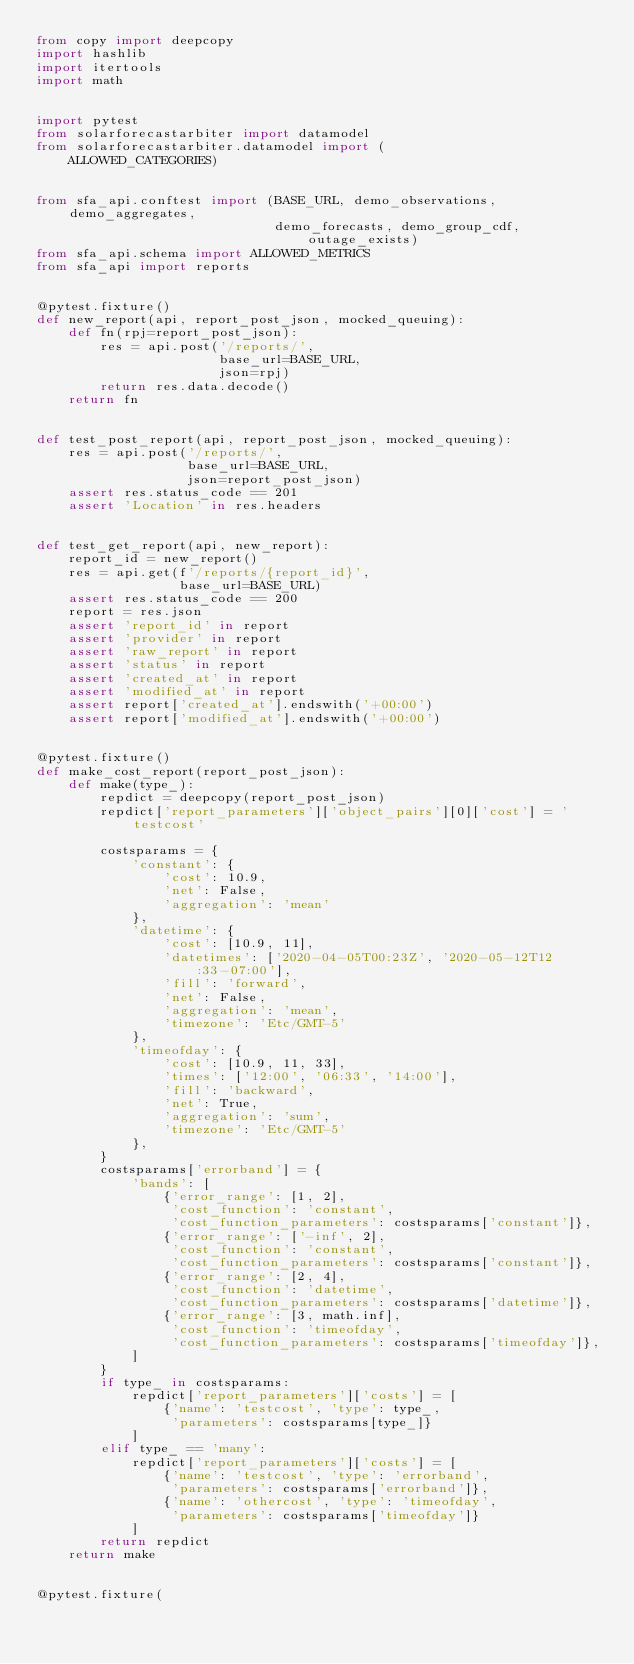Convert code to text. <code><loc_0><loc_0><loc_500><loc_500><_Python_>from copy import deepcopy
import hashlib
import itertools
import math


import pytest
from solarforecastarbiter import datamodel
from solarforecastarbiter.datamodel import (
    ALLOWED_CATEGORIES)


from sfa_api.conftest import (BASE_URL, demo_observations, demo_aggregates,
                              demo_forecasts, demo_group_cdf, outage_exists)
from sfa_api.schema import ALLOWED_METRICS
from sfa_api import reports


@pytest.fixture()
def new_report(api, report_post_json, mocked_queuing):
    def fn(rpj=report_post_json):
        res = api.post('/reports/',
                       base_url=BASE_URL,
                       json=rpj)
        return res.data.decode()
    return fn


def test_post_report(api, report_post_json, mocked_queuing):
    res = api.post('/reports/',
                   base_url=BASE_URL,
                   json=report_post_json)
    assert res.status_code == 201
    assert 'Location' in res.headers


def test_get_report(api, new_report):
    report_id = new_report()
    res = api.get(f'/reports/{report_id}',
                  base_url=BASE_URL)
    assert res.status_code == 200
    report = res.json
    assert 'report_id' in report
    assert 'provider' in report
    assert 'raw_report' in report
    assert 'status' in report
    assert 'created_at' in report
    assert 'modified_at' in report
    assert report['created_at'].endswith('+00:00')
    assert report['modified_at'].endswith('+00:00')


@pytest.fixture()
def make_cost_report(report_post_json):
    def make(type_):
        repdict = deepcopy(report_post_json)
        repdict['report_parameters']['object_pairs'][0]['cost'] = 'testcost'

        costsparams = {
            'constant': {
                'cost': 10.9,
                'net': False,
                'aggregation': 'mean'
            },
            'datetime': {
                'cost': [10.9, 11],
                'datetimes': ['2020-04-05T00:23Z', '2020-05-12T12:33-07:00'],
                'fill': 'forward',
                'net': False,
                'aggregation': 'mean',
                'timezone': 'Etc/GMT-5'
            },
            'timeofday': {
                'cost': [10.9, 11, 33],
                'times': ['12:00', '06:33', '14:00'],
                'fill': 'backward',
                'net': True,
                'aggregation': 'sum',
                'timezone': 'Etc/GMT-5'
            },
        }
        costsparams['errorband'] = {
            'bands': [
                {'error_range': [1, 2],
                 'cost_function': 'constant',
                 'cost_function_parameters': costsparams['constant']},
                {'error_range': ['-inf', 2],
                 'cost_function': 'constant',
                 'cost_function_parameters': costsparams['constant']},
                {'error_range': [2, 4],
                 'cost_function': 'datetime',
                 'cost_function_parameters': costsparams['datetime']},
                {'error_range': [3, math.inf],
                 'cost_function': 'timeofday',
                 'cost_function_parameters': costsparams['timeofday']},
            ]
        }
        if type_ in costsparams:
            repdict['report_parameters']['costs'] = [
                {'name': 'testcost', 'type': type_,
                 'parameters': costsparams[type_]}
            ]
        elif type_ == 'many':
            repdict['report_parameters']['costs'] = [
                {'name': 'testcost', 'type': 'errorband',
                 'parameters': costsparams['errorband']},
                {'name': 'othercost', 'type': 'timeofday',
                 'parameters': costsparams['timeofday']}
            ]
        return repdict
    return make


@pytest.fixture(</code> 